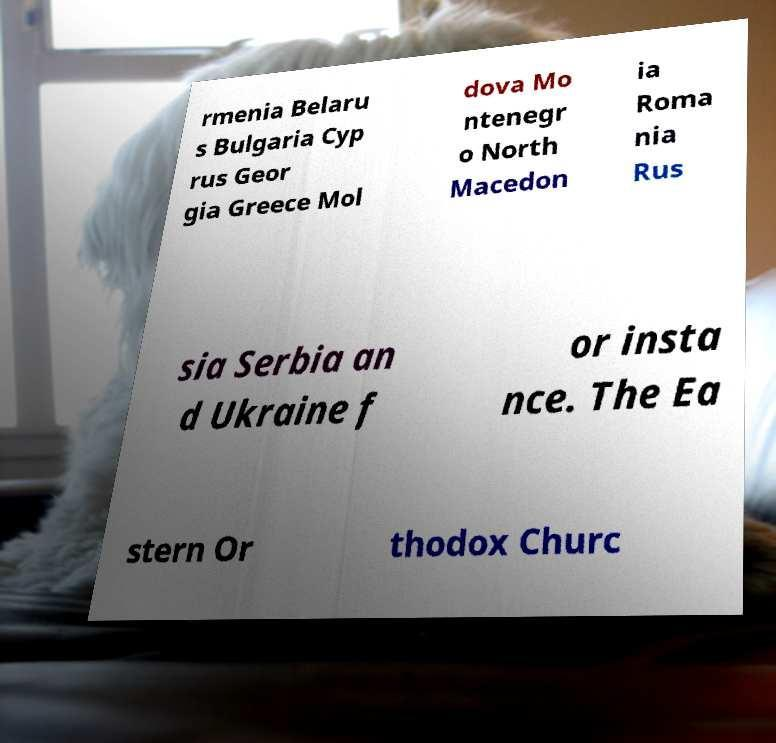Please read and relay the text visible in this image. What does it say? rmenia Belaru s Bulgaria Cyp rus Geor gia Greece Mol dova Mo ntenegr o North Macedon ia Roma nia Rus sia Serbia an d Ukraine f or insta nce. The Ea stern Or thodox Churc 